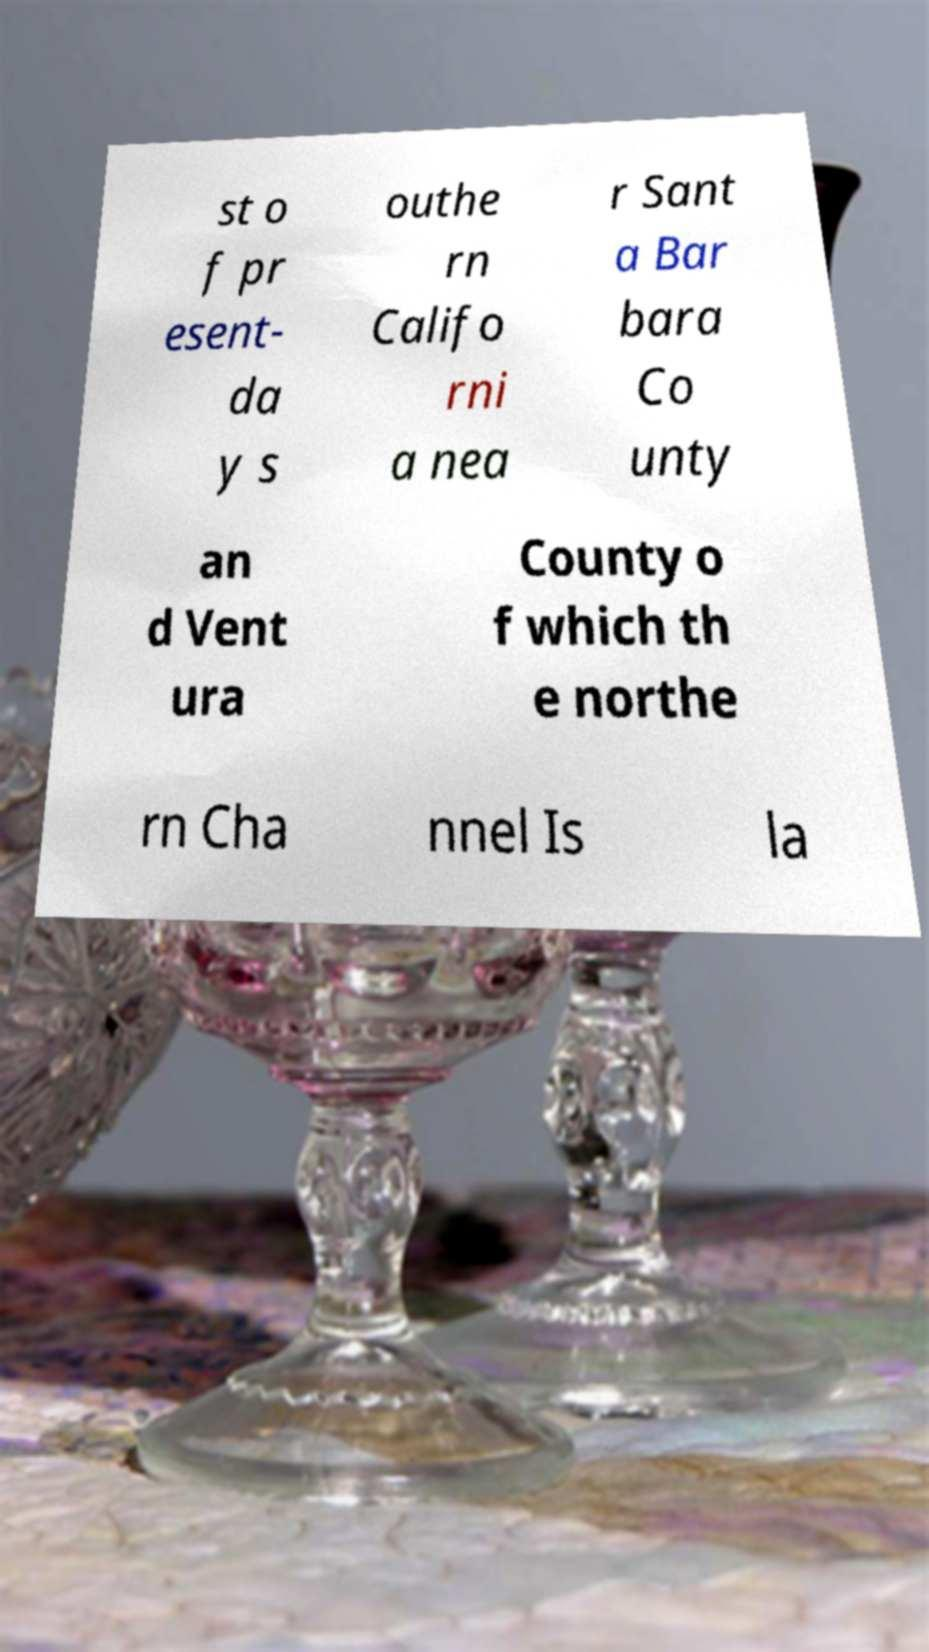Can you accurately transcribe the text from the provided image for me? st o f pr esent- da y s outhe rn Califo rni a nea r Sant a Bar bara Co unty an d Vent ura County o f which th e northe rn Cha nnel Is la 